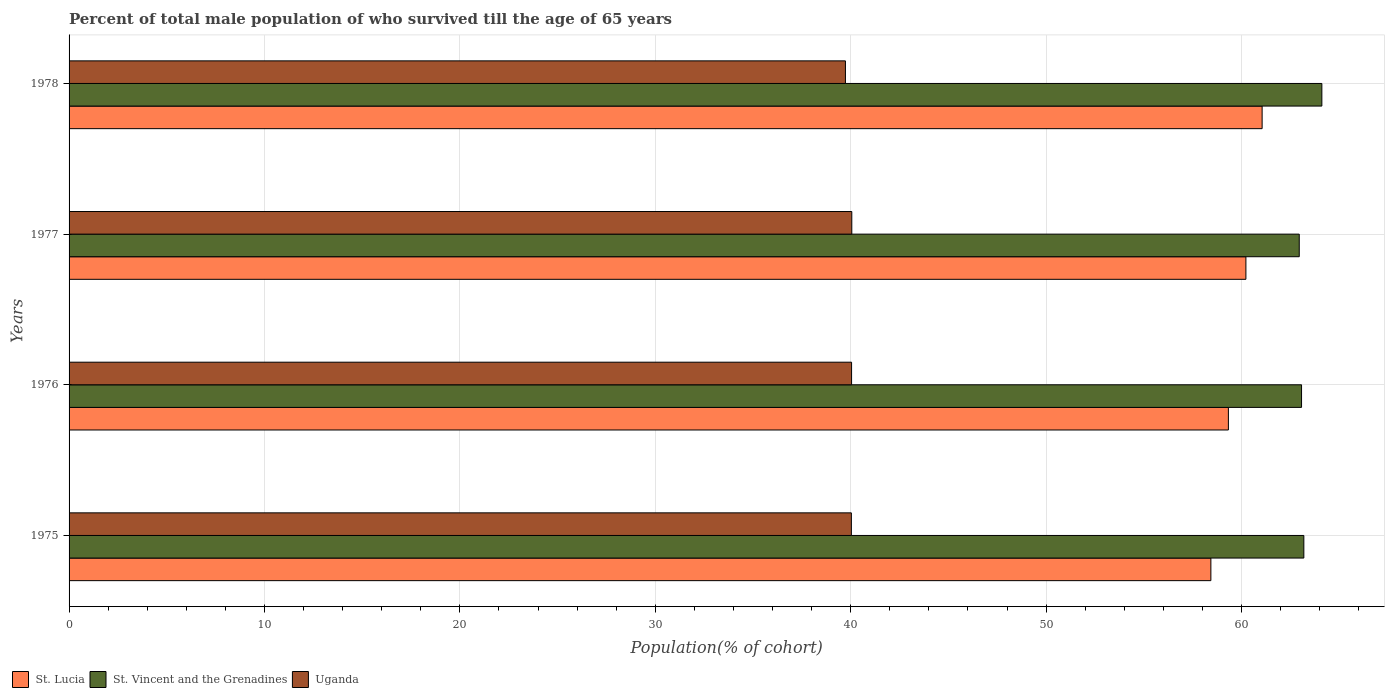How many different coloured bars are there?
Keep it short and to the point. 3. Are the number of bars on each tick of the Y-axis equal?
Your answer should be compact. Yes. How many bars are there on the 3rd tick from the top?
Your response must be concise. 3. How many bars are there on the 1st tick from the bottom?
Provide a short and direct response. 3. What is the label of the 1st group of bars from the top?
Keep it short and to the point. 1978. What is the percentage of total male population who survived till the age of 65 years in St. Vincent and the Grenadines in 1975?
Ensure brevity in your answer.  63.19. Across all years, what is the maximum percentage of total male population who survived till the age of 65 years in St. Vincent and the Grenadines?
Make the answer very short. 64.11. Across all years, what is the minimum percentage of total male population who survived till the age of 65 years in St. Lucia?
Offer a terse response. 58.43. In which year was the percentage of total male population who survived till the age of 65 years in St. Vincent and the Grenadines maximum?
Keep it short and to the point. 1978. What is the total percentage of total male population who survived till the age of 65 years in Uganda in the graph?
Make the answer very short. 159.86. What is the difference between the percentage of total male population who survived till the age of 65 years in St. Lucia in 1976 and that in 1978?
Your answer should be very brief. -1.73. What is the difference between the percentage of total male population who survived till the age of 65 years in St. Vincent and the Grenadines in 1975 and the percentage of total male population who survived till the age of 65 years in Uganda in 1976?
Offer a terse response. 23.14. What is the average percentage of total male population who survived till the age of 65 years in Uganda per year?
Keep it short and to the point. 39.96. In the year 1978, what is the difference between the percentage of total male population who survived till the age of 65 years in St. Lucia and percentage of total male population who survived till the age of 65 years in Uganda?
Keep it short and to the point. 21.32. What is the ratio of the percentage of total male population who survived till the age of 65 years in St. Lucia in 1976 to that in 1977?
Your answer should be very brief. 0.99. Is the percentage of total male population who survived till the age of 65 years in Uganda in 1976 less than that in 1978?
Keep it short and to the point. No. What is the difference between the highest and the second highest percentage of total male population who survived till the age of 65 years in St. Lucia?
Provide a short and direct response. 0.83. What is the difference between the highest and the lowest percentage of total male population who survived till the age of 65 years in St. Lucia?
Provide a short and direct response. 2.62. In how many years, is the percentage of total male population who survived till the age of 65 years in St. Vincent and the Grenadines greater than the average percentage of total male population who survived till the age of 65 years in St. Vincent and the Grenadines taken over all years?
Provide a short and direct response. 1. Is the sum of the percentage of total male population who survived till the age of 65 years in St. Lucia in 1976 and 1977 greater than the maximum percentage of total male population who survived till the age of 65 years in St. Vincent and the Grenadines across all years?
Your answer should be very brief. Yes. What does the 1st bar from the top in 1977 represents?
Give a very brief answer. Uganda. What does the 1st bar from the bottom in 1978 represents?
Give a very brief answer. St. Lucia. Is it the case that in every year, the sum of the percentage of total male population who survived till the age of 65 years in St. Vincent and the Grenadines and percentage of total male population who survived till the age of 65 years in St. Lucia is greater than the percentage of total male population who survived till the age of 65 years in Uganda?
Your answer should be compact. Yes. How many bars are there?
Give a very brief answer. 12. Are all the bars in the graph horizontal?
Make the answer very short. Yes. How many years are there in the graph?
Keep it short and to the point. 4. Are the values on the major ticks of X-axis written in scientific E-notation?
Keep it short and to the point. No. Where does the legend appear in the graph?
Your response must be concise. Bottom left. How many legend labels are there?
Keep it short and to the point. 3. How are the legend labels stacked?
Your answer should be very brief. Horizontal. What is the title of the graph?
Give a very brief answer. Percent of total male population of who survived till the age of 65 years. Does "Europe(developing only)" appear as one of the legend labels in the graph?
Offer a terse response. No. What is the label or title of the X-axis?
Provide a succinct answer. Population(% of cohort). What is the label or title of the Y-axis?
Provide a short and direct response. Years. What is the Population(% of cohort) of St. Lucia in 1975?
Provide a succinct answer. 58.43. What is the Population(% of cohort) in St. Vincent and the Grenadines in 1975?
Offer a terse response. 63.19. What is the Population(% of cohort) of Uganda in 1975?
Offer a very short reply. 40.03. What is the Population(% of cohort) in St. Lucia in 1976?
Make the answer very short. 59.33. What is the Population(% of cohort) of St. Vincent and the Grenadines in 1976?
Ensure brevity in your answer.  63.07. What is the Population(% of cohort) in Uganda in 1976?
Your answer should be compact. 40.04. What is the Population(% of cohort) of St. Lucia in 1977?
Offer a terse response. 60.22. What is the Population(% of cohort) of St. Vincent and the Grenadines in 1977?
Ensure brevity in your answer.  62.95. What is the Population(% of cohort) in Uganda in 1977?
Your response must be concise. 40.05. What is the Population(% of cohort) of St. Lucia in 1978?
Ensure brevity in your answer.  61.05. What is the Population(% of cohort) of St. Vincent and the Grenadines in 1978?
Your answer should be very brief. 64.11. What is the Population(% of cohort) in Uganda in 1978?
Your answer should be compact. 39.73. Across all years, what is the maximum Population(% of cohort) in St. Lucia?
Ensure brevity in your answer.  61.05. Across all years, what is the maximum Population(% of cohort) in St. Vincent and the Grenadines?
Provide a succinct answer. 64.11. Across all years, what is the maximum Population(% of cohort) in Uganda?
Give a very brief answer. 40.05. Across all years, what is the minimum Population(% of cohort) in St. Lucia?
Keep it short and to the point. 58.43. Across all years, what is the minimum Population(% of cohort) in St. Vincent and the Grenadines?
Ensure brevity in your answer.  62.95. Across all years, what is the minimum Population(% of cohort) of Uganda?
Your response must be concise. 39.73. What is the total Population(% of cohort) in St. Lucia in the graph?
Your response must be concise. 239.03. What is the total Population(% of cohort) in St. Vincent and the Grenadines in the graph?
Keep it short and to the point. 253.31. What is the total Population(% of cohort) in Uganda in the graph?
Your answer should be compact. 159.86. What is the difference between the Population(% of cohort) in St. Lucia in 1975 and that in 1976?
Ensure brevity in your answer.  -0.9. What is the difference between the Population(% of cohort) of St. Vincent and the Grenadines in 1975 and that in 1976?
Provide a short and direct response. 0.12. What is the difference between the Population(% of cohort) of Uganda in 1975 and that in 1976?
Make the answer very short. -0.01. What is the difference between the Population(% of cohort) of St. Lucia in 1975 and that in 1977?
Provide a succinct answer. -1.79. What is the difference between the Population(% of cohort) of St. Vincent and the Grenadines in 1975 and that in 1977?
Your response must be concise. 0.24. What is the difference between the Population(% of cohort) of Uganda in 1975 and that in 1977?
Provide a succinct answer. -0.02. What is the difference between the Population(% of cohort) of St. Lucia in 1975 and that in 1978?
Make the answer very short. -2.62. What is the difference between the Population(% of cohort) of St. Vincent and the Grenadines in 1975 and that in 1978?
Provide a short and direct response. -0.92. What is the difference between the Population(% of cohort) of Uganda in 1975 and that in 1978?
Your response must be concise. 0.3. What is the difference between the Population(% of cohort) of St. Lucia in 1976 and that in 1977?
Offer a terse response. -0.9. What is the difference between the Population(% of cohort) in St. Vincent and the Grenadines in 1976 and that in 1977?
Your response must be concise. 0.12. What is the difference between the Population(% of cohort) of Uganda in 1976 and that in 1977?
Your response must be concise. -0.01. What is the difference between the Population(% of cohort) in St. Lucia in 1976 and that in 1978?
Provide a short and direct response. -1.73. What is the difference between the Population(% of cohort) in St. Vincent and the Grenadines in 1976 and that in 1978?
Keep it short and to the point. -1.04. What is the difference between the Population(% of cohort) in Uganda in 1976 and that in 1978?
Make the answer very short. 0.31. What is the difference between the Population(% of cohort) in St. Lucia in 1977 and that in 1978?
Provide a short and direct response. -0.83. What is the difference between the Population(% of cohort) of St. Vincent and the Grenadines in 1977 and that in 1978?
Your answer should be compact. -1.16. What is the difference between the Population(% of cohort) of Uganda in 1977 and that in 1978?
Offer a very short reply. 0.33. What is the difference between the Population(% of cohort) in St. Lucia in 1975 and the Population(% of cohort) in St. Vincent and the Grenadines in 1976?
Your answer should be compact. -4.64. What is the difference between the Population(% of cohort) in St. Lucia in 1975 and the Population(% of cohort) in Uganda in 1976?
Make the answer very short. 18.39. What is the difference between the Population(% of cohort) of St. Vincent and the Grenadines in 1975 and the Population(% of cohort) of Uganda in 1976?
Provide a succinct answer. 23.14. What is the difference between the Population(% of cohort) of St. Lucia in 1975 and the Population(% of cohort) of St. Vincent and the Grenadines in 1977?
Your answer should be very brief. -4.52. What is the difference between the Population(% of cohort) in St. Lucia in 1975 and the Population(% of cohort) in Uganda in 1977?
Keep it short and to the point. 18.38. What is the difference between the Population(% of cohort) in St. Vincent and the Grenadines in 1975 and the Population(% of cohort) in Uganda in 1977?
Provide a short and direct response. 23.13. What is the difference between the Population(% of cohort) in St. Lucia in 1975 and the Population(% of cohort) in St. Vincent and the Grenadines in 1978?
Make the answer very short. -5.68. What is the difference between the Population(% of cohort) in St. Lucia in 1975 and the Population(% of cohort) in Uganda in 1978?
Offer a terse response. 18.7. What is the difference between the Population(% of cohort) in St. Vincent and the Grenadines in 1975 and the Population(% of cohort) in Uganda in 1978?
Your answer should be compact. 23.46. What is the difference between the Population(% of cohort) in St. Lucia in 1976 and the Population(% of cohort) in St. Vincent and the Grenadines in 1977?
Keep it short and to the point. -3.63. What is the difference between the Population(% of cohort) in St. Lucia in 1976 and the Population(% of cohort) in Uganda in 1977?
Your response must be concise. 19.27. What is the difference between the Population(% of cohort) in St. Vincent and the Grenadines in 1976 and the Population(% of cohort) in Uganda in 1977?
Keep it short and to the point. 23.02. What is the difference between the Population(% of cohort) in St. Lucia in 1976 and the Population(% of cohort) in St. Vincent and the Grenadines in 1978?
Give a very brief answer. -4.78. What is the difference between the Population(% of cohort) of St. Lucia in 1976 and the Population(% of cohort) of Uganda in 1978?
Offer a terse response. 19.6. What is the difference between the Population(% of cohort) of St. Vincent and the Grenadines in 1976 and the Population(% of cohort) of Uganda in 1978?
Offer a very short reply. 23.34. What is the difference between the Population(% of cohort) of St. Lucia in 1977 and the Population(% of cohort) of St. Vincent and the Grenadines in 1978?
Give a very brief answer. -3.89. What is the difference between the Population(% of cohort) in St. Lucia in 1977 and the Population(% of cohort) in Uganda in 1978?
Make the answer very short. 20.49. What is the difference between the Population(% of cohort) in St. Vincent and the Grenadines in 1977 and the Population(% of cohort) in Uganda in 1978?
Offer a very short reply. 23.22. What is the average Population(% of cohort) in St. Lucia per year?
Your answer should be compact. 59.76. What is the average Population(% of cohort) of St. Vincent and the Grenadines per year?
Make the answer very short. 63.33. What is the average Population(% of cohort) in Uganda per year?
Provide a short and direct response. 39.96. In the year 1975, what is the difference between the Population(% of cohort) of St. Lucia and Population(% of cohort) of St. Vincent and the Grenadines?
Make the answer very short. -4.76. In the year 1975, what is the difference between the Population(% of cohort) of St. Lucia and Population(% of cohort) of Uganda?
Your answer should be very brief. 18.4. In the year 1975, what is the difference between the Population(% of cohort) in St. Vincent and the Grenadines and Population(% of cohort) in Uganda?
Offer a terse response. 23.15. In the year 1976, what is the difference between the Population(% of cohort) of St. Lucia and Population(% of cohort) of St. Vincent and the Grenadines?
Provide a succinct answer. -3.74. In the year 1976, what is the difference between the Population(% of cohort) in St. Lucia and Population(% of cohort) in Uganda?
Your response must be concise. 19.28. In the year 1976, what is the difference between the Population(% of cohort) in St. Vincent and the Grenadines and Population(% of cohort) in Uganda?
Offer a very short reply. 23.03. In the year 1977, what is the difference between the Population(% of cohort) in St. Lucia and Population(% of cohort) in St. Vincent and the Grenadines?
Your response must be concise. -2.73. In the year 1977, what is the difference between the Population(% of cohort) in St. Lucia and Population(% of cohort) in Uganda?
Make the answer very short. 20.17. In the year 1977, what is the difference between the Population(% of cohort) in St. Vincent and the Grenadines and Population(% of cohort) in Uganda?
Your response must be concise. 22.9. In the year 1978, what is the difference between the Population(% of cohort) in St. Lucia and Population(% of cohort) in St. Vincent and the Grenadines?
Make the answer very short. -3.06. In the year 1978, what is the difference between the Population(% of cohort) of St. Lucia and Population(% of cohort) of Uganda?
Give a very brief answer. 21.32. In the year 1978, what is the difference between the Population(% of cohort) in St. Vincent and the Grenadines and Population(% of cohort) in Uganda?
Ensure brevity in your answer.  24.38. What is the ratio of the Population(% of cohort) in St. Lucia in 1975 to that in 1976?
Provide a short and direct response. 0.98. What is the ratio of the Population(% of cohort) in St. Vincent and the Grenadines in 1975 to that in 1976?
Your answer should be very brief. 1. What is the ratio of the Population(% of cohort) in Uganda in 1975 to that in 1976?
Make the answer very short. 1. What is the ratio of the Population(% of cohort) of St. Lucia in 1975 to that in 1977?
Provide a succinct answer. 0.97. What is the ratio of the Population(% of cohort) of Uganda in 1975 to that in 1977?
Offer a terse response. 1. What is the ratio of the Population(% of cohort) in St. Lucia in 1975 to that in 1978?
Your answer should be very brief. 0.96. What is the ratio of the Population(% of cohort) in St. Vincent and the Grenadines in 1975 to that in 1978?
Your answer should be compact. 0.99. What is the ratio of the Population(% of cohort) of Uganda in 1975 to that in 1978?
Your answer should be compact. 1.01. What is the ratio of the Population(% of cohort) in St. Lucia in 1976 to that in 1977?
Your answer should be very brief. 0.99. What is the ratio of the Population(% of cohort) in St. Vincent and the Grenadines in 1976 to that in 1977?
Keep it short and to the point. 1. What is the ratio of the Population(% of cohort) of Uganda in 1976 to that in 1977?
Your answer should be very brief. 1. What is the ratio of the Population(% of cohort) in St. Lucia in 1976 to that in 1978?
Your response must be concise. 0.97. What is the ratio of the Population(% of cohort) of St. Vincent and the Grenadines in 1976 to that in 1978?
Keep it short and to the point. 0.98. What is the ratio of the Population(% of cohort) in Uganda in 1976 to that in 1978?
Give a very brief answer. 1.01. What is the ratio of the Population(% of cohort) in St. Lucia in 1977 to that in 1978?
Provide a short and direct response. 0.99. What is the ratio of the Population(% of cohort) in Uganda in 1977 to that in 1978?
Provide a succinct answer. 1.01. What is the difference between the highest and the second highest Population(% of cohort) in St. Lucia?
Your response must be concise. 0.83. What is the difference between the highest and the second highest Population(% of cohort) in St. Vincent and the Grenadines?
Offer a very short reply. 0.92. What is the difference between the highest and the second highest Population(% of cohort) in Uganda?
Provide a succinct answer. 0.01. What is the difference between the highest and the lowest Population(% of cohort) in St. Lucia?
Your response must be concise. 2.62. What is the difference between the highest and the lowest Population(% of cohort) of St. Vincent and the Grenadines?
Offer a very short reply. 1.16. What is the difference between the highest and the lowest Population(% of cohort) of Uganda?
Give a very brief answer. 0.33. 